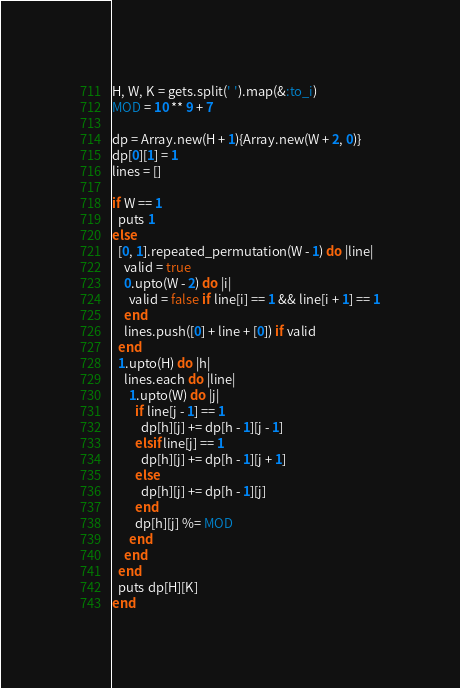Convert code to text. <code><loc_0><loc_0><loc_500><loc_500><_Ruby_>H, W, K = gets.split(' ').map(&:to_i)
MOD = 10 ** 9 + 7

dp = Array.new(H + 1){Array.new(W + 2, 0)}
dp[0][1] = 1
lines = []

if W == 1
  puts 1
else
  [0, 1].repeated_permutation(W - 1) do |line|
    valid = true
    0.upto(W - 2) do |i|
      valid = false if line[i] == 1 && line[i + 1] == 1
    end
    lines.push([0] + line + [0]) if valid
  end
  1.upto(H) do |h|
    lines.each do |line|
      1.upto(W) do |j|
        if line[j - 1] == 1
          dp[h][j] += dp[h - 1][j - 1]
        elsif line[j] == 1
          dp[h][j] += dp[h - 1][j + 1]
        else
          dp[h][j] += dp[h - 1][j]
        end
        dp[h][j] %= MOD
      end
    end
  end
  puts dp[H][K]
end</code> 